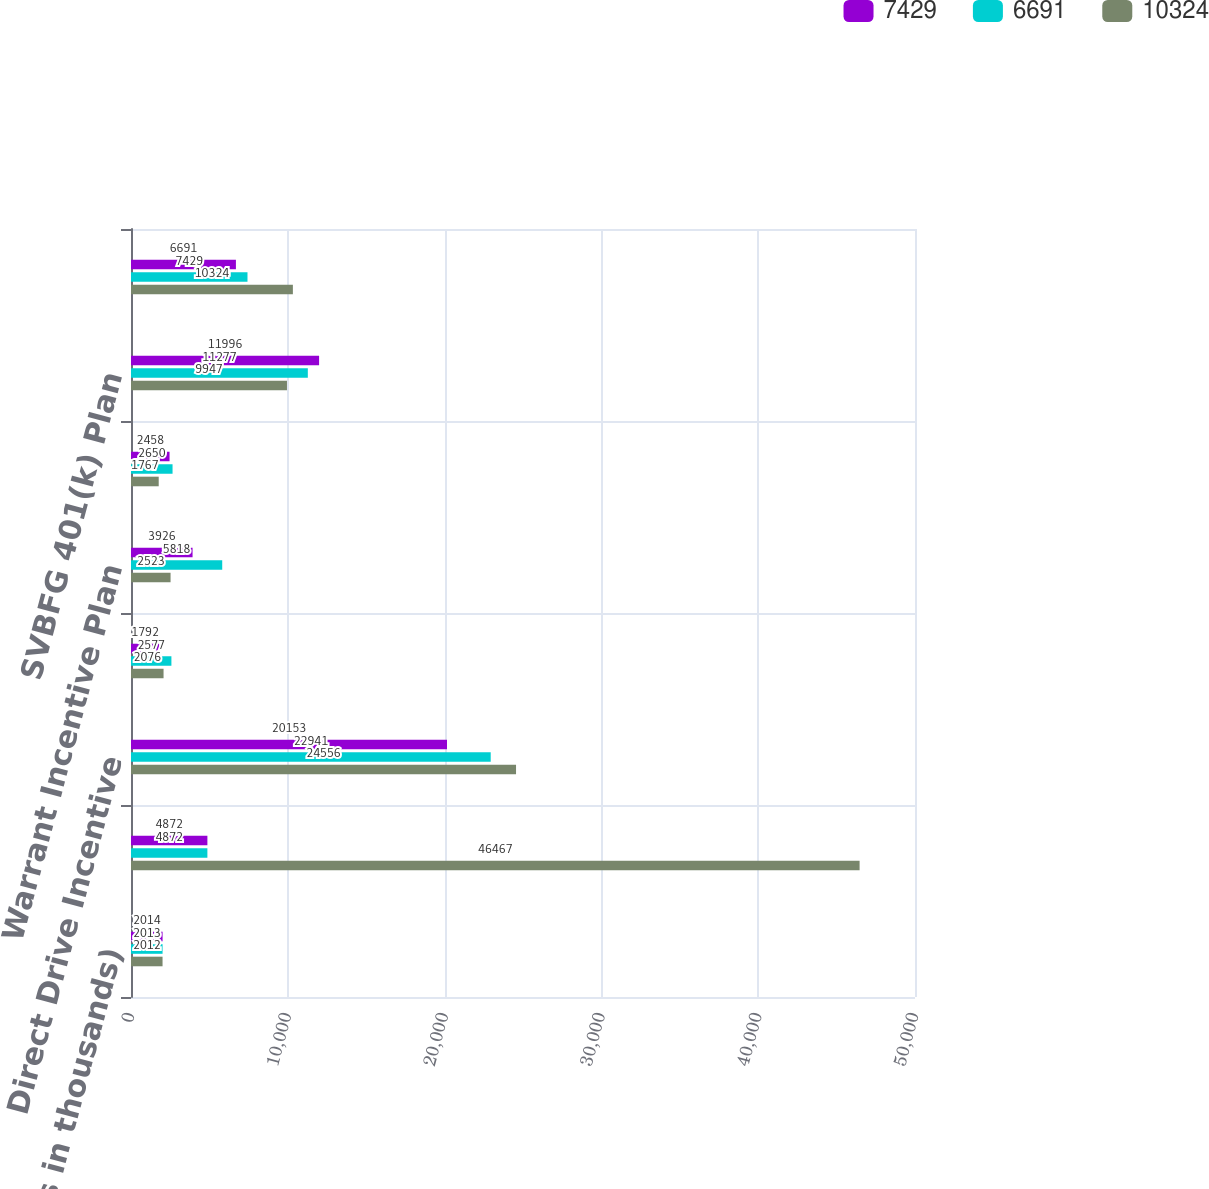Convert chart. <chart><loc_0><loc_0><loc_500><loc_500><stacked_bar_chart><ecel><fcel>(Dollars in thousands)<fcel>Incentive Compensation Plan<fcel>Direct Drive Incentive<fcel>Retention Program<fcel>Warrant Incentive Plan<fcel>Deferred Compensation Plan<fcel>SVBFG 401(k) Plan<fcel>SVBFG ESOP<nl><fcel>7429<fcel>2014<fcel>4872<fcel>20153<fcel>1792<fcel>3926<fcel>2458<fcel>11996<fcel>6691<nl><fcel>6691<fcel>2013<fcel>4872<fcel>22941<fcel>2577<fcel>5818<fcel>2650<fcel>11277<fcel>7429<nl><fcel>10324<fcel>2012<fcel>46467<fcel>24556<fcel>2076<fcel>2523<fcel>1767<fcel>9947<fcel>10324<nl></chart> 